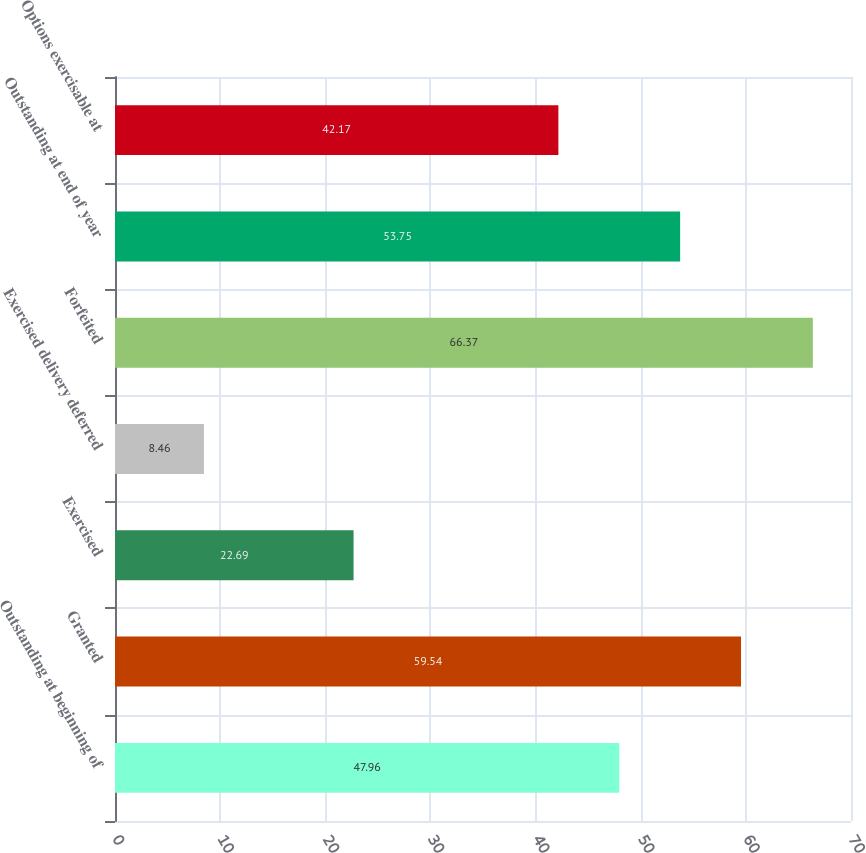Convert chart. <chart><loc_0><loc_0><loc_500><loc_500><bar_chart><fcel>Outstanding at beginning of<fcel>Granted<fcel>Exercised<fcel>Exercised delivery deferred<fcel>Forfeited<fcel>Outstanding at end of year<fcel>Options exercisable at<nl><fcel>47.96<fcel>59.54<fcel>22.69<fcel>8.46<fcel>66.37<fcel>53.75<fcel>42.17<nl></chart> 